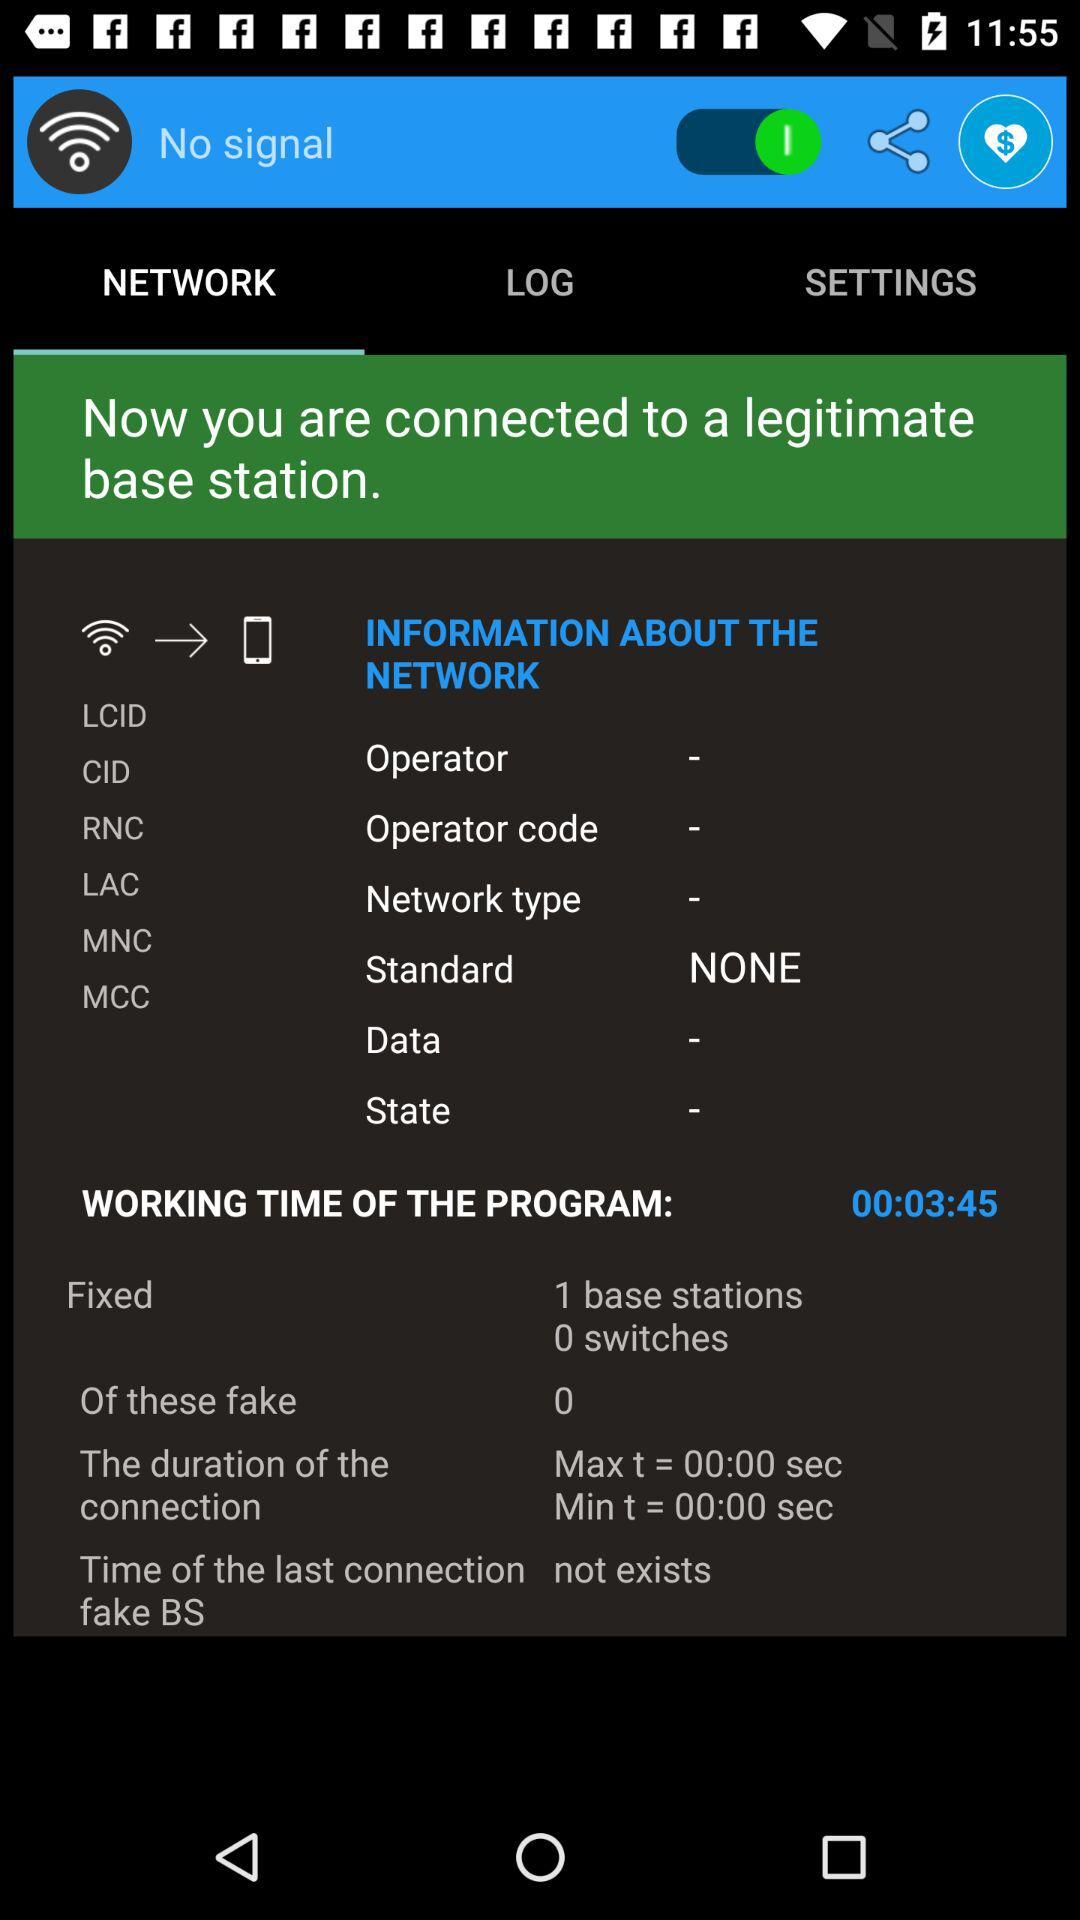How many fake base stations have been detected?
Answer the question using a single word or phrase. 0 